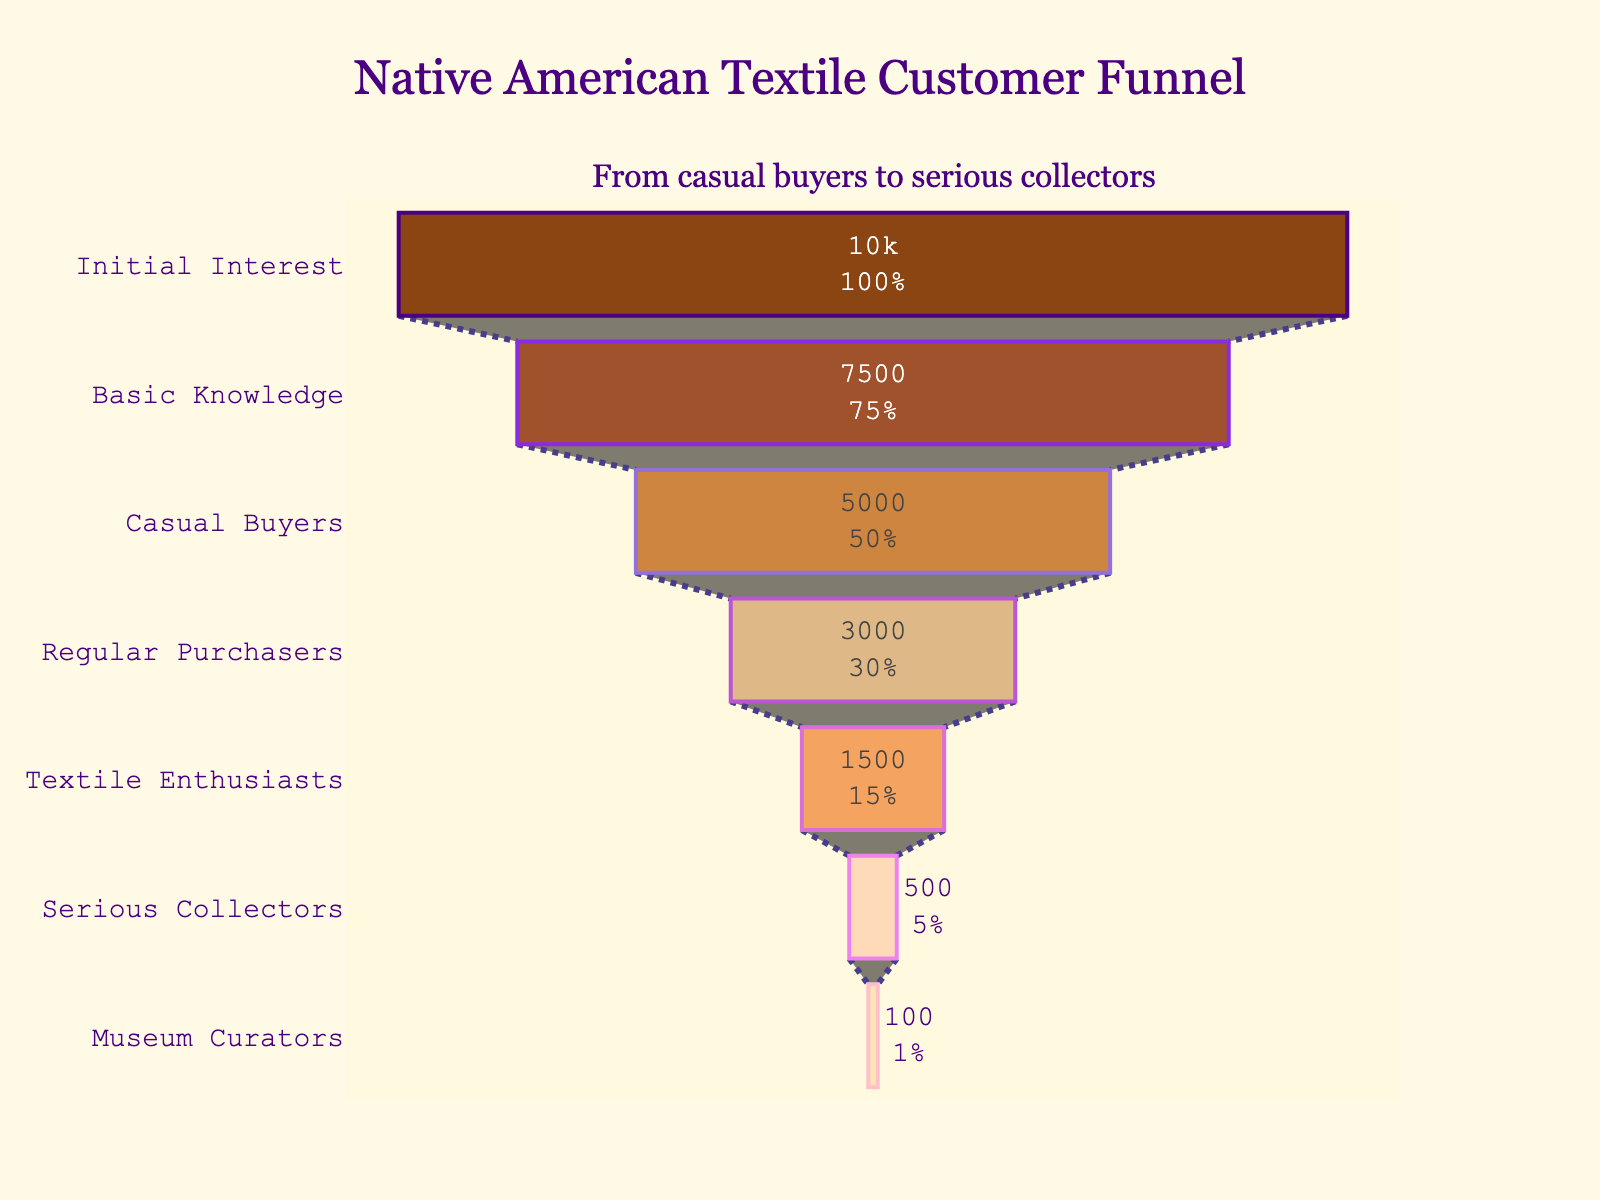What is the title of the funnel chart? The title is displayed at the top-center of the chart.
Answer: Native American Textile Customer Funnel How many stages are displayed in the funnel chart? Counting the y-axis labels vertically from top to bottom.
Answer: 7 Which stage has the greatest number of customers? By checking the x-values associated with each y-axis stage, the highest value corresponds to the "Initial Interest" stage.
Answer: Initial Interest What is the percentage of "Serious Collectors" compared to "Initial Interest"? "Serious Collectors" have 500 customers and "Initial Interest" has 10000 customers. Calculate the percentage as (500 / 10000) * 100.
Answer: 5% What is the difference in the number of customers between "Regular Purchasers" and "Museum Curators"? The number of customers for "Regular Purchasers" is 3000 and for "Museum Curators" is 100. Calculate the difference as 3000 - 100.
Answer: 2900 What stage has the least number of customers? Identify the smallest x-value among the given data points.
Answer: Museum Curators How many customers are lost between the "Basic Knowledge" and "Casual Buyers" stages? The number of customers for "Basic Knowledge" is 7500 and for "Casual Buyers" is 5000. Calculate the difference as 7500 - 5000.
Answer: 2500 Which stage comes right after "Regular Purchasers"? Identify the stage immediately following "Regular Purchasers" on the y-axis.
Answer: Textile Enthusiasts How many customers transition from "Textile Enthusiasts" to "Serious Collectors"? The number of customers for "Textile Enthusiasts" is 1500, and for "Serious Collectors," it is 500. Calculate the difference as 1500 - 500.
Answer: 1000 What is the overall trend shown by the funnel? Observing the x-values decreasing from top to bottom in order.
Answer: Decreasing 